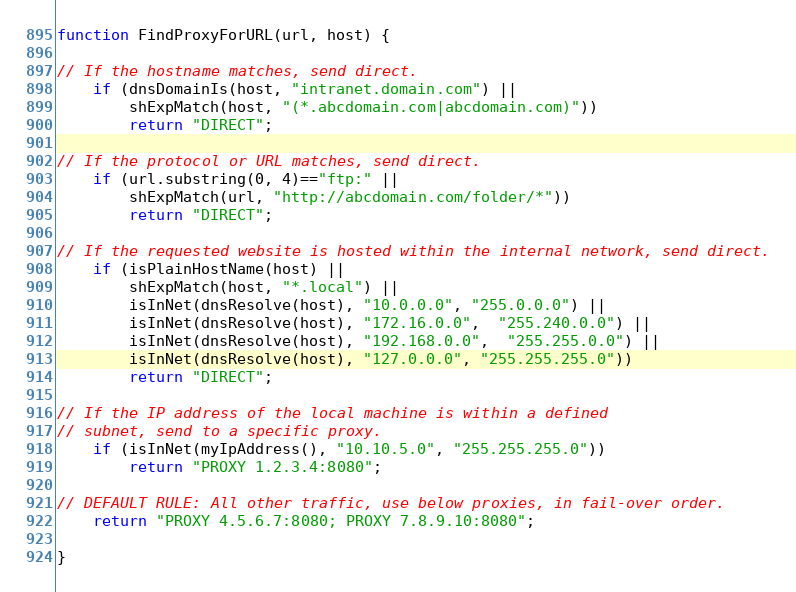<code> <loc_0><loc_0><loc_500><loc_500><_JavaScript_>function FindProxyForURL(url, host) {

// If the hostname matches, send direct.
    if (dnsDomainIs(host, "intranet.domain.com") ||
        shExpMatch(host, "(*.abcdomain.com|abcdomain.com)"))
        return "DIRECT";

// If the protocol or URL matches, send direct.
    if (url.substring(0, 4)=="ftp:" ||
        shExpMatch(url, "http://abcdomain.com/folder/*"))
        return "DIRECT";

// If the requested website is hosted within the internal network, send direct.
    if (isPlainHostName(host) ||
        shExpMatch(host, "*.local") ||
        isInNet(dnsResolve(host), "10.0.0.0", "255.0.0.0") ||
        isInNet(dnsResolve(host), "172.16.0.0",  "255.240.0.0") ||
        isInNet(dnsResolve(host), "192.168.0.0",  "255.255.0.0") ||
        isInNet(dnsResolve(host), "127.0.0.0", "255.255.255.0"))
        return "DIRECT";

// If the IP address of the local machine is within a defined
// subnet, send to a specific proxy.
    if (isInNet(myIpAddress(), "10.10.5.0", "255.255.255.0"))
        return "PROXY 1.2.3.4:8080";

// DEFAULT RULE: All other traffic, use below proxies, in fail-over order.
    return "PROXY 4.5.6.7:8080; PROXY 7.8.9.10:8080";

}
</code> 